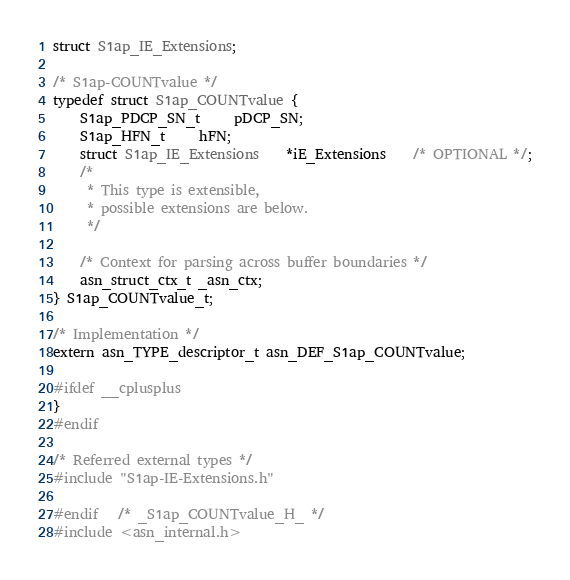<code> <loc_0><loc_0><loc_500><loc_500><_C_>struct S1ap_IE_Extensions;

/* S1ap-COUNTvalue */
typedef struct S1ap_COUNTvalue {
	S1ap_PDCP_SN_t	 pDCP_SN;
	S1ap_HFN_t	 hFN;
	struct S1ap_IE_Extensions	*iE_Extensions	/* OPTIONAL */;
	/*
	 * This type is extensible,
	 * possible extensions are below.
	 */
	
	/* Context for parsing across buffer boundaries */
	asn_struct_ctx_t _asn_ctx;
} S1ap_COUNTvalue_t;

/* Implementation */
extern asn_TYPE_descriptor_t asn_DEF_S1ap_COUNTvalue;

#ifdef __cplusplus
}
#endif

/* Referred external types */
#include "S1ap-IE-Extensions.h"

#endif	/* _S1ap_COUNTvalue_H_ */
#include <asn_internal.h>
</code> 